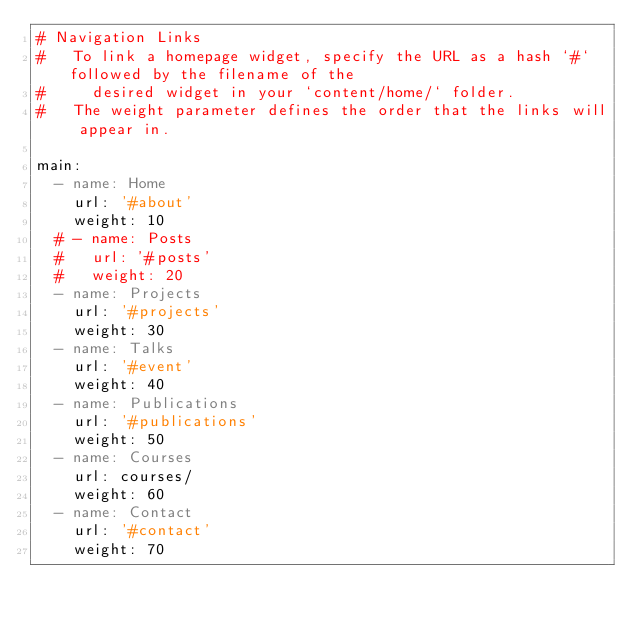Convert code to text. <code><loc_0><loc_0><loc_500><loc_500><_YAML_># Navigation Links
#   To link a homepage widget, specify the URL as a hash `#` followed by the filename of the
#     desired widget in your `content/home/` folder.
#   The weight parameter defines the order that the links will appear in.

main:
  - name: Home
    url: '#about'
    weight: 10
  # - name: Posts
  #   url: '#posts'
  #   weight: 20
  - name: Projects
    url: '#projects'
    weight: 30
  - name: Talks
    url: '#event'
    weight: 40
  - name: Publications
    url: '#publications'
    weight: 50
  - name: Courses
    url: courses/
    weight: 60
  - name: Contact
    url: '#contact'
    weight: 70
</code> 